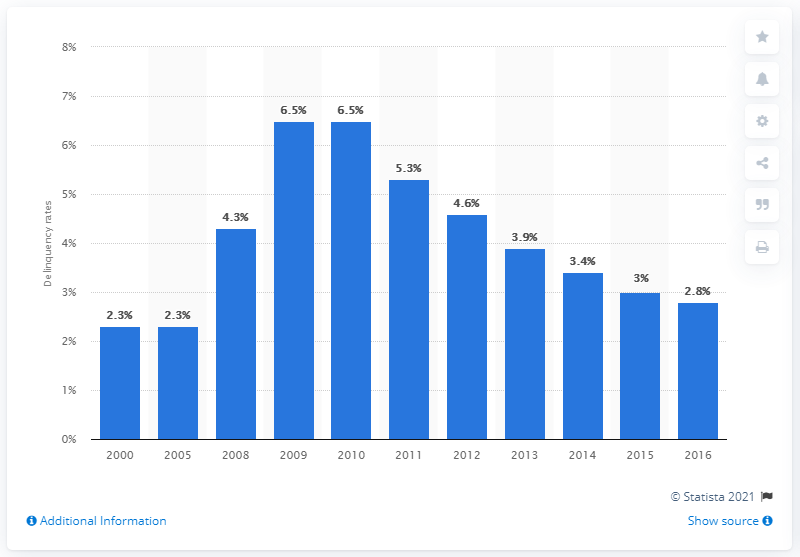Identify some key points in this picture. In 2016, the mortgage delinquency rate for prime conventional loans in the United States was 2.8%. 